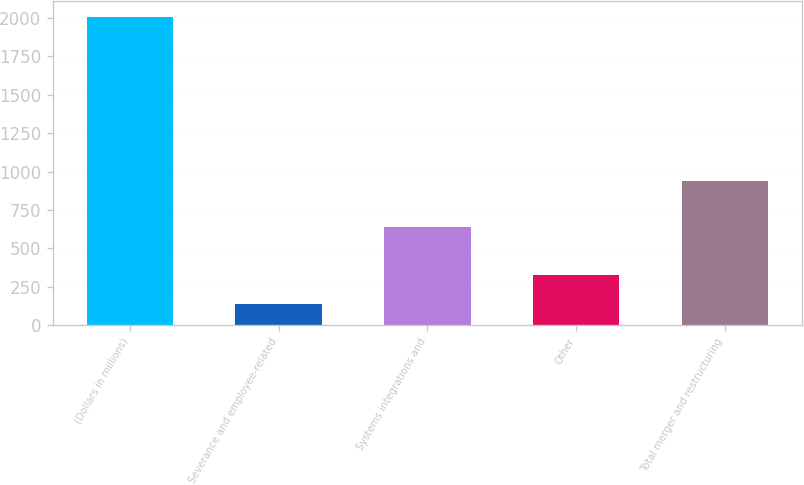<chart> <loc_0><loc_0><loc_500><loc_500><bar_chart><fcel>(Dollars in millions)<fcel>Severance and employee-related<fcel>Systems integrations and<fcel>Other<fcel>Total merger and restructuring<nl><fcel>2008<fcel>138<fcel>640<fcel>325<fcel>935<nl></chart> 